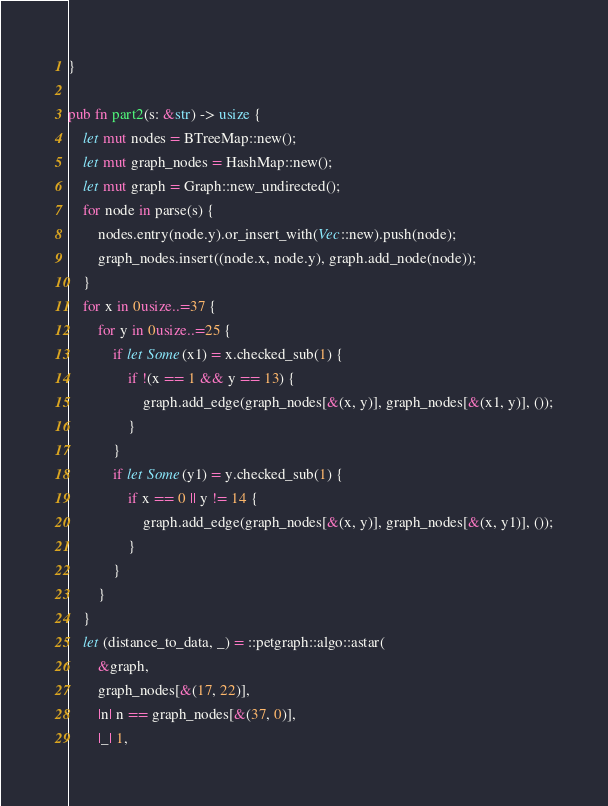<code> <loc_0><loc_0><loc_500><loc_500><_Rust_>}

pub fn part2(s: &str) -> usize {
    let mut nodes = BTreeMap::new();
    let mut graph_nodes = HashMap::new();
    let mut graph = Graph::new_undirected();
    for node in parse(s) {
        nodes.entry(node.y).or_insert_with(Vec::new).push(node);
        graph_nodes.insert((node.x, node.y), graph.add_node(node));
    }
    for x in 0usize..=37 {
        for y in 0usize..=25 {
            if let Some(x1) = x.checked_sub(1) {
                if !(x == 1 && y == 13) {
                    graph.add_edge(graph_nodes[&(x, y)], graph_nodes[&(x1, y)], ());
                }
            }
            if let Some(y1) = y.checked_sub(1) {
                if x == 0 || y != 14 {
                    graph.add_edge(graph_nodes[&(x, y)], graph_nodes[&(x, y1)], ());
                }
            }
        }
    }
    let (distance_to_data, _) = ::petgraph::algo::astar(
        &graph,
        graph_nodes[&(17, 22)],
        |n| n == graph_nodes[&(37, 0)],
        |_| 1,</code> 